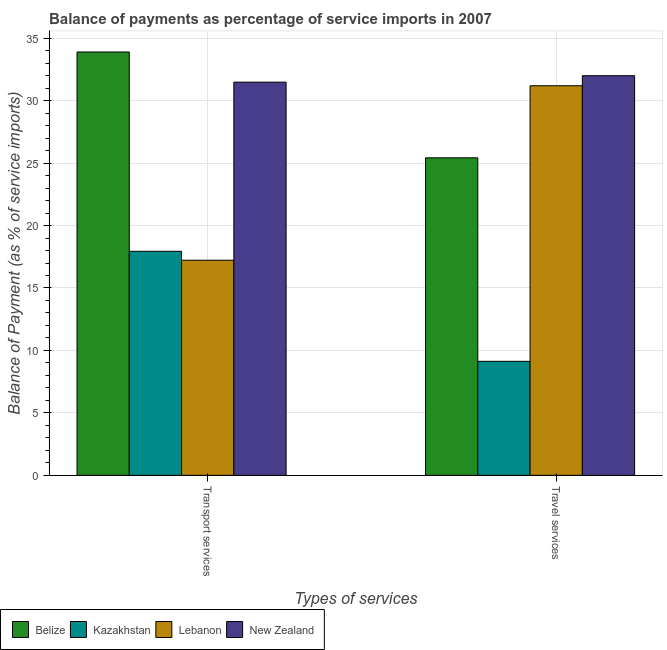How many different coloured bars are there?
Your answer should be compact. 4. How many bars are there on the 1st tick from the left?
Give a very brief answer. 4. How many bars are there on the 2nd tick from the right?
Make the answer very short. 4. What is the label of the 2nd group of bars from the left?
Your answer should be very brief. Travel services. What is the balance of payments of transport services in Belize?
Your answer should be compact. 33.89. Across all countries, what is the maximum balance of payments of transport services?
Give a very brief answer. 33.89. Across all countries, what is the minimum balance of payments of transport services?
Offer a terse response. 17.22. In which country was the balance of payments of travel services maximum?
Your answer should be very brief. New Zealand. In which country was the balance of payments of travel services minimum?
Make the answer very short. Kazakhstan. What is the total balance of payments of travel services in the graph?
Offer a terse response. 97.74. What is the difference between the balance of payments of travel services in Kazakhstan and that in Lebanon?
Keep it short and to the point. -22.06. What is the difference between the balance of payments of transport services in Lebanon and the balance of payments of travel services in Belize?
Make the answer very short. -8.2. What is the average balance of payments of travel services per country?
Your answer should be very brief. 24.43. What is the difference between the balance of payments of transport services and balance of payments of travel services in Kazakhstan?
Your response must be concise. 8.81. In how many countries, is the balance of payments of travel services greater than 12 %?
Offer a terse response. 3. What is the ratio of the balance of payments of transport services in New Zealand to that in Kazakhstan?
Offer a terse response. 1.75. What does the 2nd bar from the left in Transport services represents?
Give a very brief answer. Kazakhstan. What does the 4th bar from the right in Transport services represents?
Offer a very short reply. Belize. Are all the bars in the graph horizontal?
Offer a very short reply. No. How many countries are there in the graph?
Offer a very short reply. 4. What is the difference between two consecutive major ticks on the Y-axis?
Keep it short and to the point. 5. Does the graph contain any zero values?
Offer a very short reply. No. Does the graph contain grids?
Your answer should be very brief. Yes. Where does the legend appear in the graph?
Provide a short and direct response. Bottom left. How are the legend labels stacked?
Provide a succinct answer. Horizontal. What is the title of the graph?
Offer a very short reply. Balance of payments as percentage of service imports in 2007. Does "East Asia (all income levels)" appear as one of the legend labels in the graph?
Ensure brevity in your answer.  No. What is the label or title of the X-axis?
Your answer should be compact. Types of services. What is the label or title of the Y-axis?
Your answer should be compact. Balance of Payment (as % of service imports). What is the Balance of Payment (as % of service imports) in Belize in Transport services?
Your response must be concise. 33.89. What is the Balance of Payment (as % of service imports) in Kazakhstan in Transport services?
Offer a terse response. 17.94. What is the Balance of Payment (as % of service imports) of Lebanon in Transport services?
Keep it short and to the point. 17.22. What is the Balance of Payment (as % of service imports) of New Zealand in Transport services?
Provide a succinct answer. 31.48. What is the Balance of Payment (as % of service imports) in Belize in Travel services?
Your answer should be compact. 25.42. What is the Balance of Payment (as % of service imports) of Kazakhstan in Travel services?
Offer a very short reply. 9.13. What is the Balance of Payment (as % of service imports) in Lebanon in Travel services?
Give a very brief answer. 31.19. What is the Balance of Payment (as % of service imports) in New Zealand in Travel services?
Keep it short and to the point. 32. Across all Types of services, what is the maximum Balance of Payment (as % of service imports) in Belize?
Ensure brevity in your answer.  33.89. Across all Types of services, what is the maximum Balance of Payment (as % of service imports) in Kazakhstan?
Ensure brevity in your answer.  17.94. Across all Types of services, what is the maximum Balance of Payment (as % of service imports) of Lebanon?
Make the answer very short. 31.19. Across all Types of services, what is the maximum Balance of Payment (as % of service imports) of New Zealand?
Keep it short and to the point. 32. Across all Types of services, what is the minimum Balance of Payment (as % of service imports) of Belize?
Your answer should be compact. 25.42. Across all Types of services, what is the minimum Balance of Payment (as % of service imports) of Kazakhstan?
Your response must be concise. 9.13. Across all Types of services, what is the minimum Balance of Payment (as % of service imports) of Lebanon?
Offer a very short reply. 17.22. Across all Types of services, what is the minimum Balance of Payment (as % of service imports) of New Zealand?
Ensure brevity in your answer.  31.48. What is the total Balance of Payment (as % of service imports) of Belize in the graph?
Provide a short and direct response. 59.32. What is the total Balance of Payment (as % of service imports) of Kazakhstan in the graph?
Your answer should be compact. 27.07. What is the total Balance of Payment (as % of service imports) in Lebanon in the graph?
Keep it short and to the point. 48.41. What is the total Balance of Payment (as % of service imports) in New Zealand in the graph?
Your answer should be very brief. 63.48. What is the difference between the Balance of Payment (as % of service imports) of Belize in Transport services and that in Travel services?
Keep it short and to the point. 8.47. What is the difference between the Balance of Payment (as % of service imports) in Kazakhstan in Transport services and that in Travel services?
Offer a very short reply. 8.81. What is the difference between the Balance of Payment (as % of service imports) of Lebanon in Transport services and that in Travel services?
Provide a short and direct response. -13.97. What is the difference between the Balance of Payment (as % of service imports) in New Zealand in Transport services and that in Travel services?
Make the answer very short. -0.52. What is the difference between the Balance of Payment (as % of service imports) in Belize in Transport services and the Balance of Payment (as % of service imports) in Kazakhstan in Travel services?
Your response must be concise. 24.77. What is the difference between the Balance of Payment (as % of service imports) of Belize in Transport services and the Balance of Payment (as % of service imports) of Lebanon in Travel services?
Make the answer very short. 2.7. What is the difference between the Balance of Payment (as % of service imports) in Belize in Transport services and the Balance of Payment (as % of service imports) in New Zealand in Travel services?
Make the answer very short. 1.9. What is the difference between the Balance of Payment (as % of service imports) in Kazakhstan in Transport services and the Balance of Payment (as % of service imports) in Lebanon in Travel services?
Offer a very short reply. -13.25. What is the difference between the Balance of Payment (as % of service imports) of Kazakhstan in Transport services and the Balance of Payment (as % of service imports) of New Zealand in Travel services?
Provide a succinct answer. -14.06. What is the difference between the Balance of Payment (as % of service imports) in Lebanon in Transport services and the Balance of Payment (as % of service imports) in New Zealand in Travel services?
Keep it short and to the point. -14.77. What is the average Balance of Payment (as % of service imports) in Belize per Types of services?
Your answer should be very brief. 29.66. What is the average Balance of Payment (as % of service imports) of Kazakhstan per Types of services?
Your answer should be compact. 13.53. What is the average Balance of Payment (as % of service imports) in Lebanon per Types of services?
Give a very brief answer. 24.21. What is the average Balance of Payment (as % of service imports) in New Zealand per Types of services?
Provide a succinct answer. 31.74. What is the difference between the Balance of Payment (as % of service imports) of Belize and Balance of Payment (as % of service imports) of Kazakhstan in Transport services?
Your answer should be very brief. 15.96. What is the difference between the Balance of Payment (as % of service imports) of Belize and Balance of Payment (as % of service imports) of Lebanon in Transport services?
Offer a very short reply. 16.67. What is the difference between the Balance of Payment (as % of service imports) of Belize and Balance of Payment (as % of service imports) of New Zealand in Transport services?
Your answer should be very brief. 2.41. What is the difference between the Balance of Payment (as % of service imports) in Kazakhstan and Balance of Payment (as % of service imports) in Lebanon in Transport services?
Offer a very short reply. 0.72. What is the difference between the Balance of Payment (as % of service imports) in Kazakhstan and Balance of Payment (as % of service imports) in New Zealand in Transport services?
Provide a short and direct response. -13.54. What is the difference between the Balance of Payment (as % of service imports) in Lebanon and Balance of Payment (as % of service imports) in New Zealand in Transport services?
Provide a short and direct response. -14.26. What is the difference between the Balance of Payment (as % of service imports) in Belize and Balance of Payment (as % of service imports) in Kazakhstan in Travel services?
Your answer should be compact. 16.29. What is the difference between the Balance of Payment (as % of service imports) in Belize and Balance of Payment (as % of service imports) in Lebanon in Travel services?
Provide a short and direct response. -5.77. What is the difference between the Balance of Payment (as % of service imports) in Belize and Balance of Payment (as % of service imports) in New Zealand in Travel services?
Your answer should be compact. -6.57. What is the difference between the Balance of Payment (as % of service imports) in Kazakhstan and Balance of Payment (as % of service imports) in Lebanon in Travel services?
Ensure brevity in your answer.  -22.06. What is the difference between the Balance of Payment (as % of service imports) in Kazakhstan and Balance of Payment (as % of service imports) in New Zealand in Travel services?
Give a very brief answer. -22.87. What is the difference between the Balance of Payment (as % of service imports) of Lebanon and Balance of Payment (as % of service imports) of New Zealand in Travel services?
Provide a short and direct response. -0.8. What is the ratio of the Balance of Payment (as % of service imports) in Kazakhstan in Transport services to that in Travel services?
Offer a very short reply. 1.97. What is the ratio of the Balance of Payment (as % of service imports) of Lebanon in Transport services to that in Travel services?
Ensure brevity in your answer.  0.55. What is the ratio of the Balance of Payment (as % of service imports) in New Zealand in Transport services to that in Travel services?
Give a very brief answer. 0.98. What is the difference between the highest and the second highest Balance of Payment (as % of service imports) of Belize?
Provide a short and direct response. 8.47. What is the difference between the highest and the second highest Balance of Payment (as % of service imports) in Kazakhstan?
Ensure brevity in your answer.  8.81. What is the difference between the highest and the second highest Balance of Payment (as % of service imports) in Lebanon?
Provide a short and direct response. 13.97. What is the difference between the highest and the second highest Balance of Payment (as % of service imports) of New Zealand?
Provide a succinct answer. 0.52. What is the difference between the highest and the lowest Balance of Payment (as % of service imports) of Belize?
Provide a short and direct response. 8.47. What is the difference between the highest and the lowest Balance of Payment (as % of service imports) in Kazakhstan?
Offer a terse response. 8.81. What is the difference between the highest and the lowest Balance of Payment (as % of service imports) in Lebanon?
Give a very brief answer. 13.97. What is the difference between the highest and the lowest Balance of Payment (as % of service imports) in New Zealand?
Ensure brevity in your answer.  0.52. 